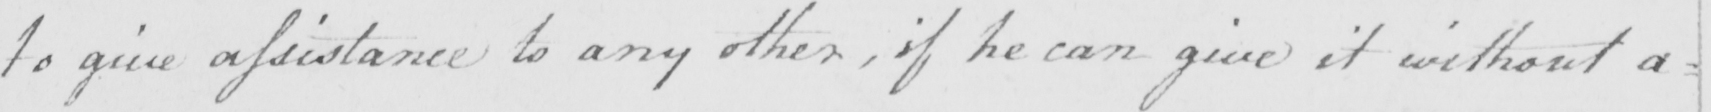What does this handwritten line say? to give assistance to any other , if he can give it without any 